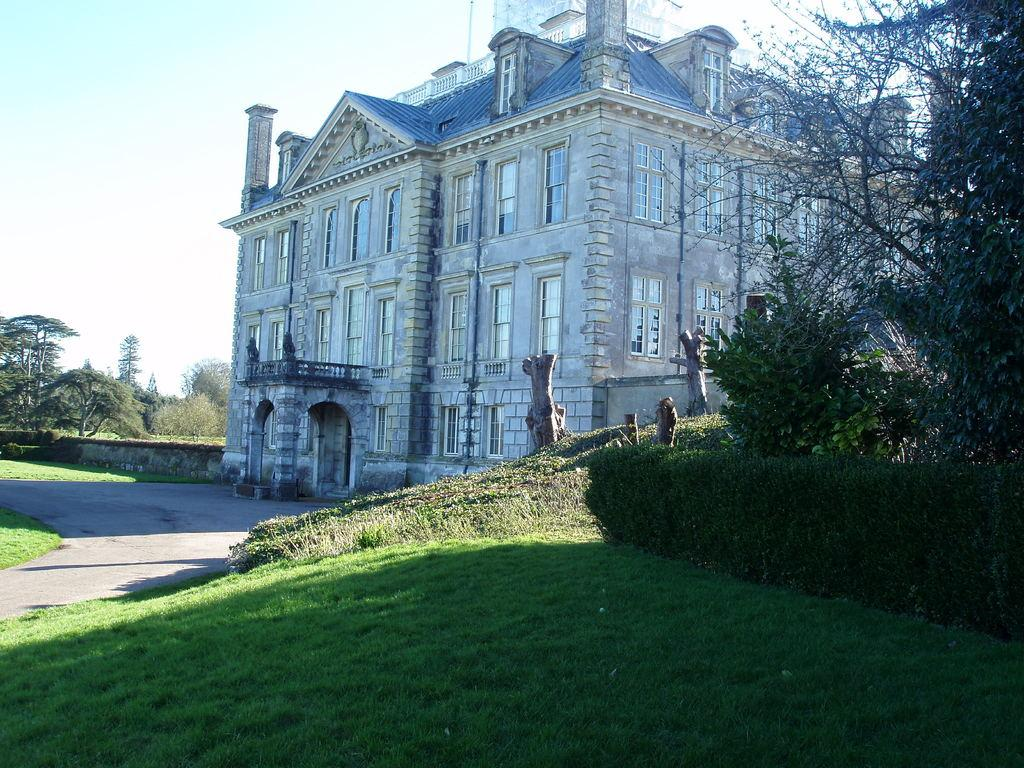What type of vegetation can be seen in the image? There is grass in the image. What other natural elements are present in the image? There are trees in the image. What structure is located in the middle of the image? There is a building in the middle of the image. What type of cake is being served by the team in the image? There is no team or cake present in the image. Can you see a kitten playing with the grass in the image? There is no kitten present in the image. 